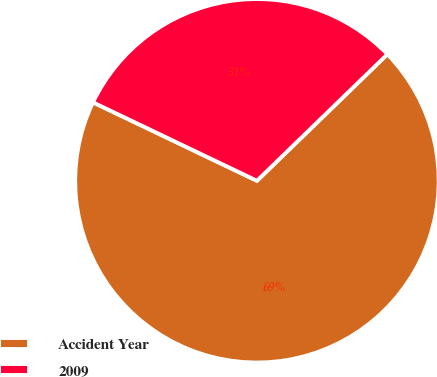<chart> <loc_0><loc_0><loc_500><loc_500><pie_chart><fcel>Accident Year<fcel>2009<nl><fcel>69.36%<fcel>30.64%<nl></chart> 